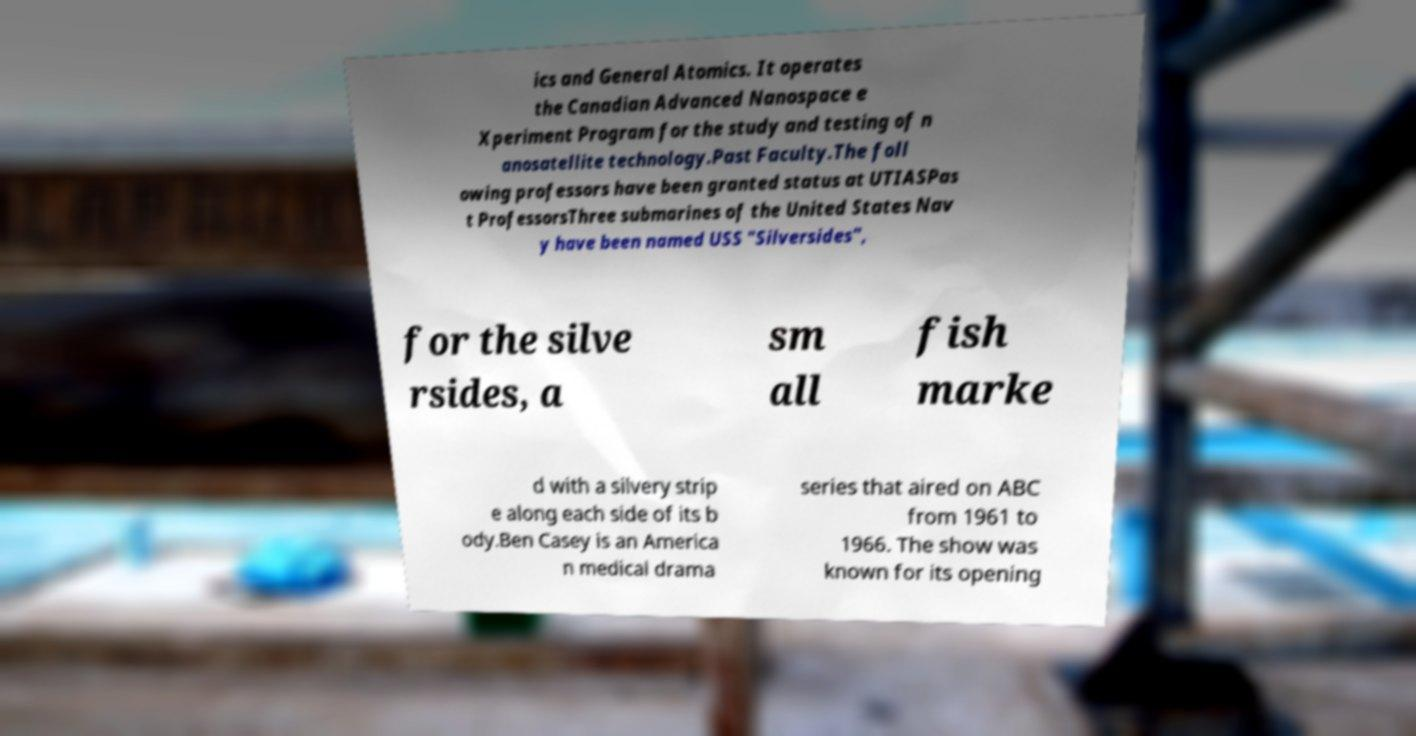Can you read and provide the text displayed in the image?This photo seems to have some interesting text. Can you extract and type it out for me? ics and General Atomics. It operates the Canadian Advanced Nanospace e Xperiment Program for the study and testing of n anosatellite technology.Past Faculty.The foll owing professors have been granted status at UTIASPas t ProfessorsThree submarines of the United States Nav y have been named USS "Silversides", for the silve rsides, a sm all fish marke d with a silvery strip e along each side of its b ody.Ben Casey is an America n medical drama series that aired on ABC from 1961 to 1966. The show was known for its opening 